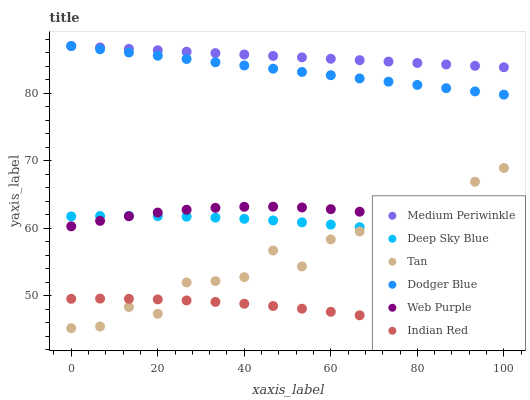Does Indian Red have the minimum area under the curve?
Answer yes or no. Yes. Does Medium Periwinkle have the maximum area under the curve?
Answer yes or no. Yes. Does Web Purple have the minimum area under the curve?
Answer yes or no. No. Does Web Purple have the maximum area under the curve?
Answer yes or no. No. Is Dodger Blue the smoothest?
Answer yes or no. Yes. Is Tan the roughest?
Answer yes or no. Yes. Is Medium Periwinkle the smoothest?
Answer yes or no. No. Is Medium Periwinkle the roughest?
Answer yes or no. No. Does Indian Red have the lowest value?
Answer yes or no. Yes. Does Web Purple have the lowest value?
Answer yes or no. No. Does Dodger Blue have the highest value?
Answer yes or no. Yes. Does Web Purple have the highest value?
Answer yes or no. No. Is Deep Sky Blue less than Dodger Blue?
Answer yes or no. Yes. Is Dodger Blue greater than Tan?
Answer yes or no. Yes. Does Web Purple intersect Tan?
Answer yes or no. Yes. Is Web Purple less than Tan?
Answer yes or no. No. Is Web Purple greater than Tan?
Answer yes or no. No. Does Deep Sky Blue intersect Dodger Blue?
Answer yes or no. No. 